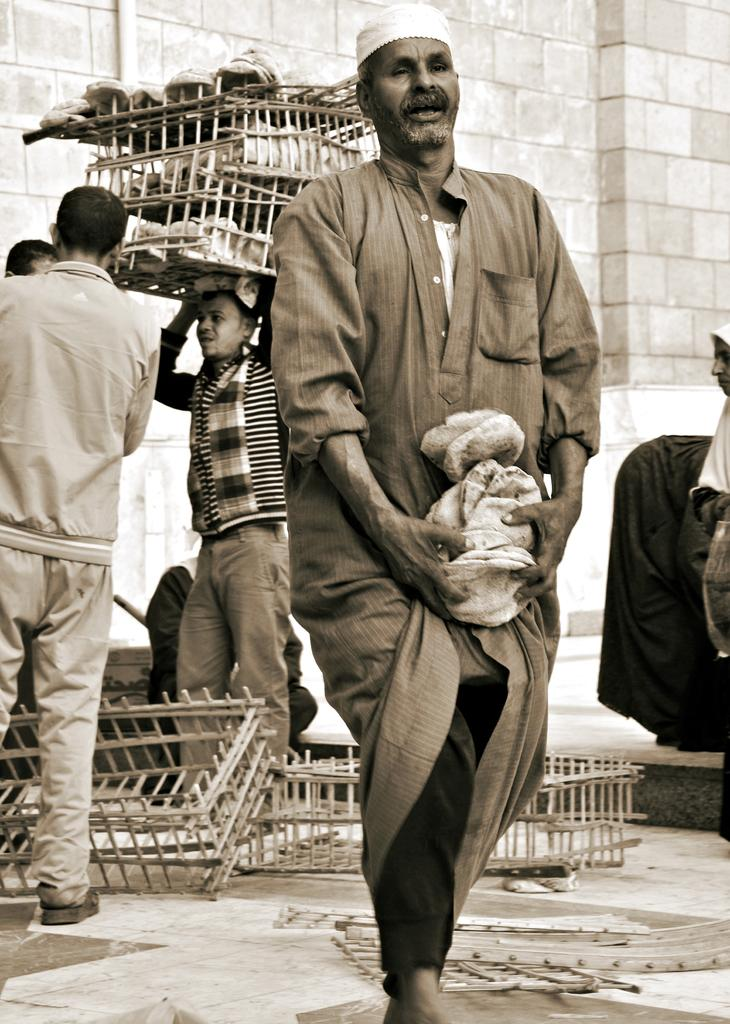What are the people in the image wearing? The people in the image are wearing dresses. What is one person doing in the image? One person is carrying baskets in the image. What can be seen in the background of the image? There is a wall visible in the background of the image. What type of pizzas are being served at the discovery event in the image? There is no discovery event or pizzas present in the image. 